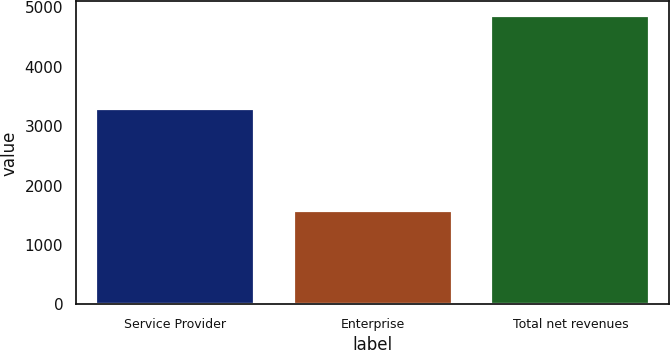<chart> <loc_0><loc_0><loc_500><loc_500><bar_chart><fcel>Service Provider<fcel>Enterprise<fcel>Total net revenues<nl><fcel>3289.8<fcel>1568<fcel>4857.8<nl></chart> 